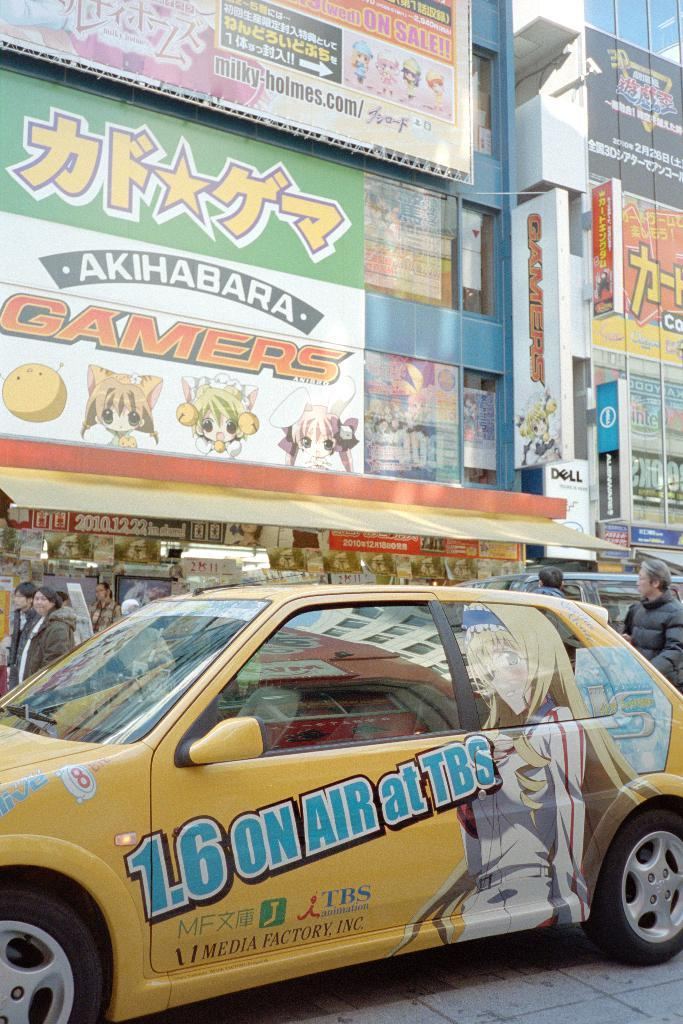<image>
Provide a brief description of the given image. A yellow car is advertising for 1.6 On Air at TBS. 